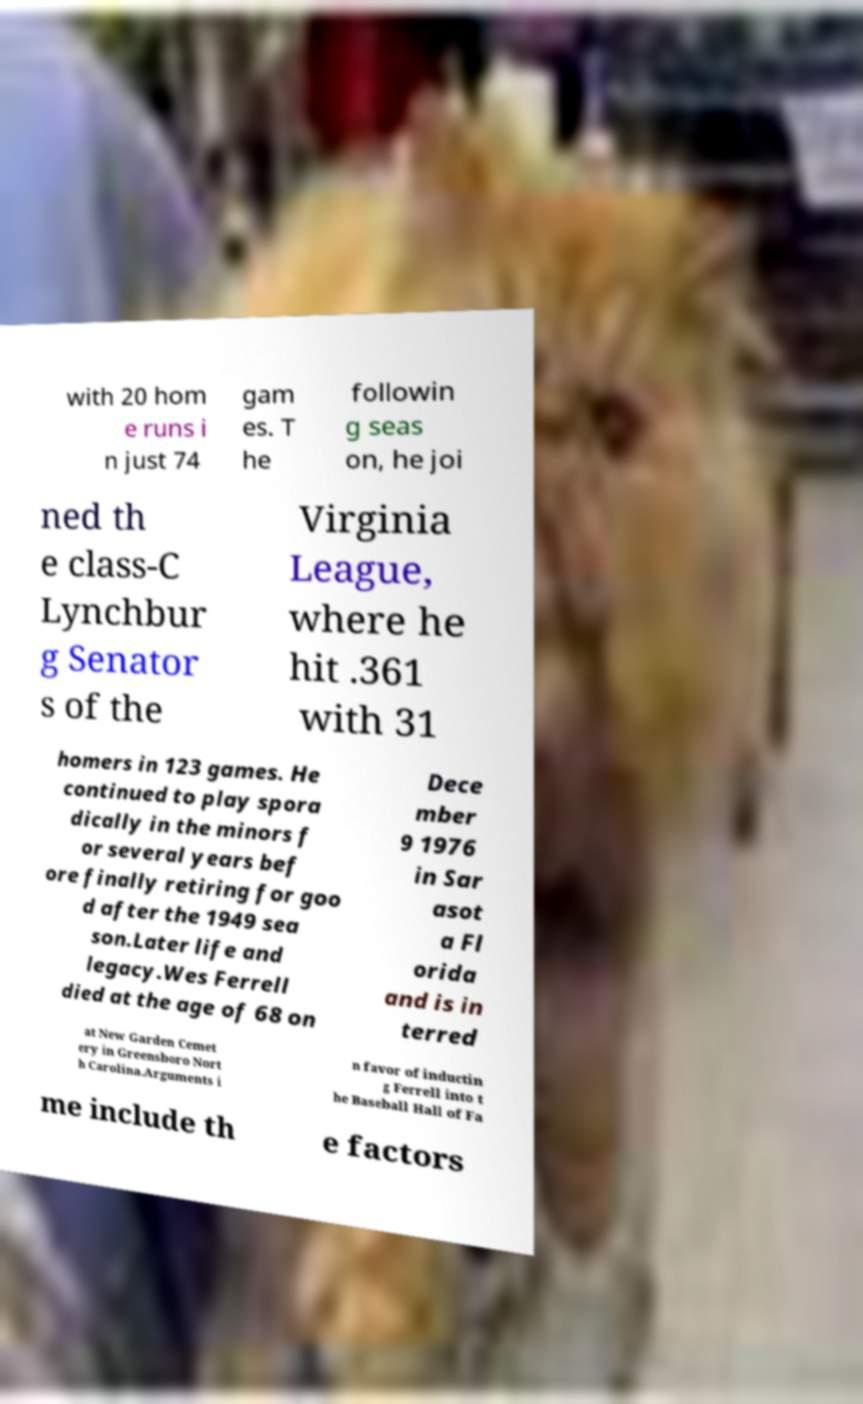There's text embedded in this image that I need extracted. Can you transcribe it verbatim? with 20 hom e runs i n just 74 gam es. T he followin g seas on, he joi ned th e class-C Lynchbur g Senator s of the Virginia League, where he hit .361 with 31 homers in 123 games. He continued to play spora dically in the minors f or several years bef ore finally retiring for goo d after the 1949 sea son.Later life and legacy.Wes Ferrell died at the age of 68 on Dece mber 9 1976 in Sar asot a Fl orida and is in terred at New Garden Cemet ery in Greensboro Nort h Carolina.Arguments i n favor of inductin g Ferrell into t he Baseball Hall of Fa me include th e factors 